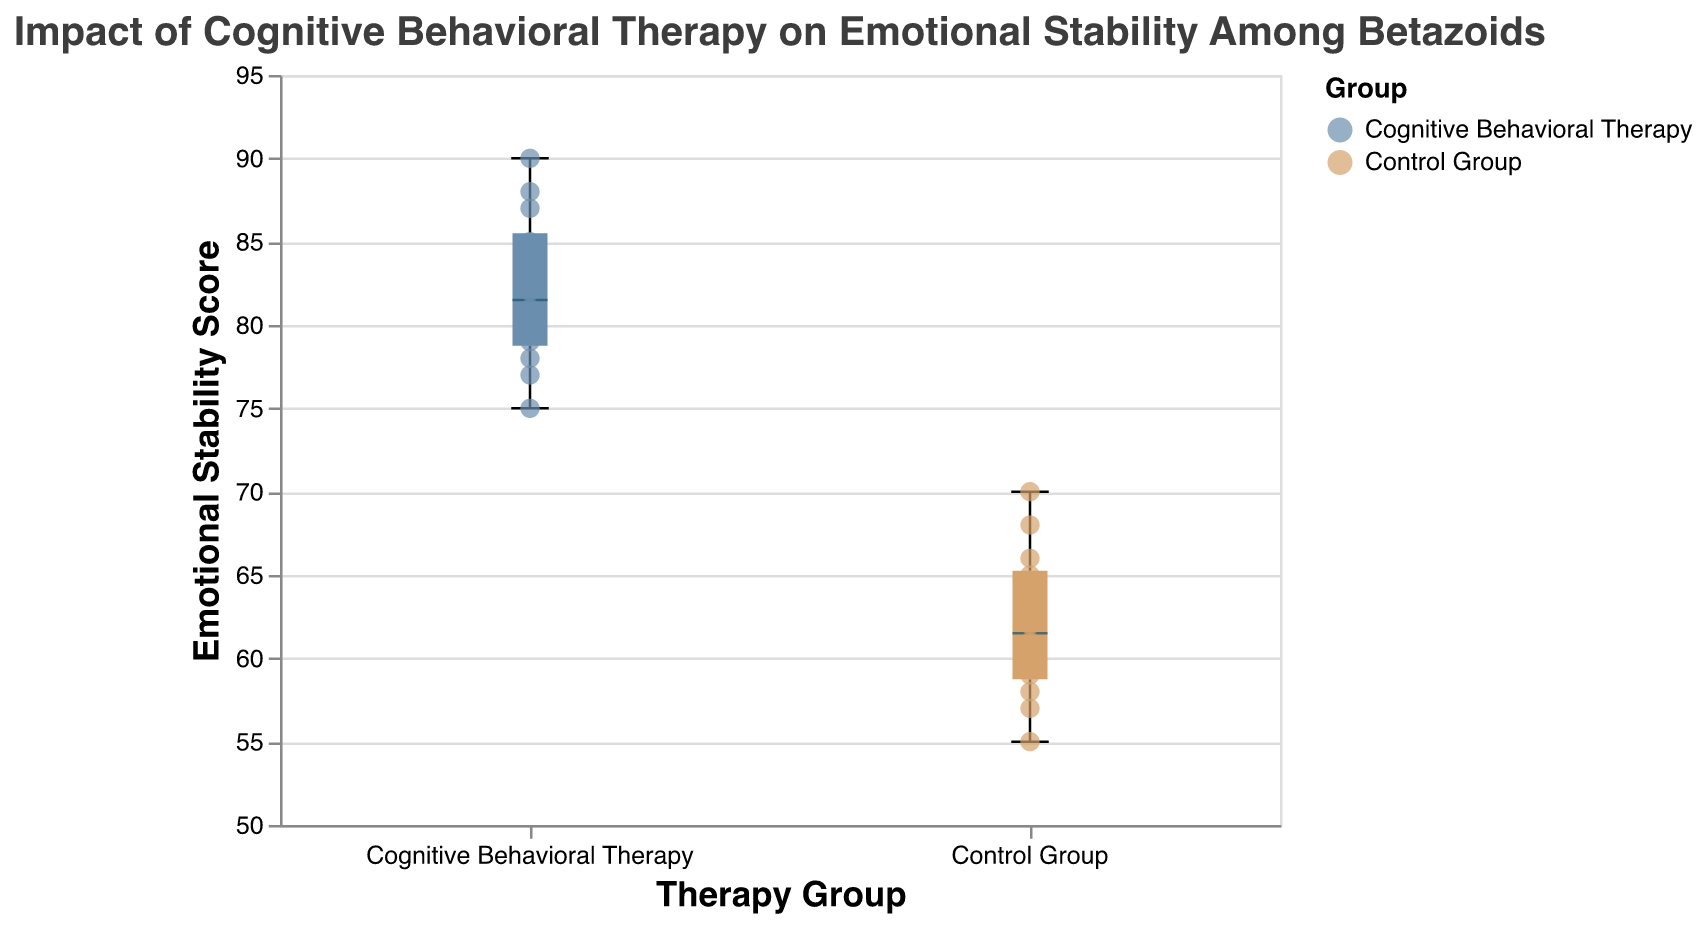What is the title of the figure? The title is displayed at the top of the figure. The text is clear and easily readable.
Answer: Impact of Cognitive Behavioral Therapy on Emotional Stability Among Betazoids Which Therapy Group shows higher emotional stability according to the box plot? The box plot shows that the Cognitive Behavioral Therapy group has higher median and overall scores compared to the Control Group.
Answer: Cognitive Behavioral Therapy What is the range of Emotional Stability Scores for the Control Group? The lowest score is 55 and the highest score is 70 in the Control Group. The range is calculated as 70 - 55.
Answer: 15 How does the median Emotional Stability Score of the Cognitive Behavioral Therapy group compare to the Control Group? The median Emotional Stability Score is marked by the line within the box. The Cognitive Behavioral Therapy group has a median score higher than that of the Control Group.
Answer: Higher Which group has a more extensive range of scores? Comparing the extent between the minimum and maximum values marked by the ends of the whiskers, the Control Group has a broader range than the Cognitive Behavioral Therapy group.
Answer: Control Group What is the highest Emotional Stability Score in the Cognitive Behavioral Therapy group? Observing the scatter points and the box plot, the highest score in the Cognitive Behavioral Therapy group is 90.
Answer: 90 What is the median score of the Control Group for Emotional Stability? The median is indicated by the horizontal line within the box. For the Control Group, this line is at 62.
Answer: 62 What are the approximate quartile ranges for the Cognitive Behavioral Therapy group? The box shows the interquartile range (IQR). The first quartile is at about 78, and the third quartile is around 85.
Answer: 78 to 85 Comparing the two groups, which group displays more variability in Emotional Stability Scores? The variability can be observed by the spread of the data points and the distance between the whiskers. The Control Group shows more variability.
Answer: Control Group How many data points are there in total in the Cognitive Behavioral Therapy group? Counting each scatter point, there are 12 data points in the Cognitive Behavioral Therapy group.
Answer: 12 